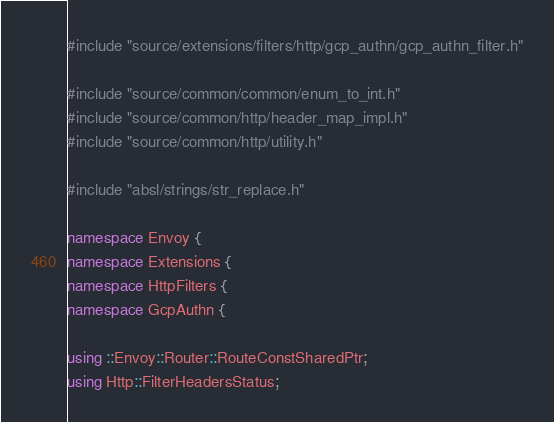<code> <loc_0><loc_0><loc_500><loc_500><_C++_>#include "source/extensions/filters/http/gcp_authn/gcp_authn_filter.h"

#include "source/common/common/enum_to_int.h"
#include "source/common/http/header_map_impl.h"
#include "source/common/http/utility.h"

#include "absl/strings/str_replace.h"

namespace Envoy {
namespace Extensions {
namespace HttpFilters {
namespace GcpAuthn {

using ::Envoy::Router::RouteConstSharedPtr;
using Http::FilterHeadersStatus;
</code> 